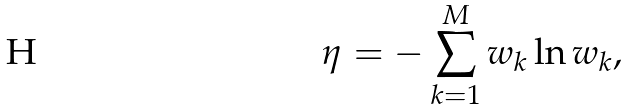<formula> <loc_0><loc_0><loc_500><loc_500>\eta = - \sum _ { k = 1 } ^ { M } w _ { k } \ln w _ { k } ,</formula> 